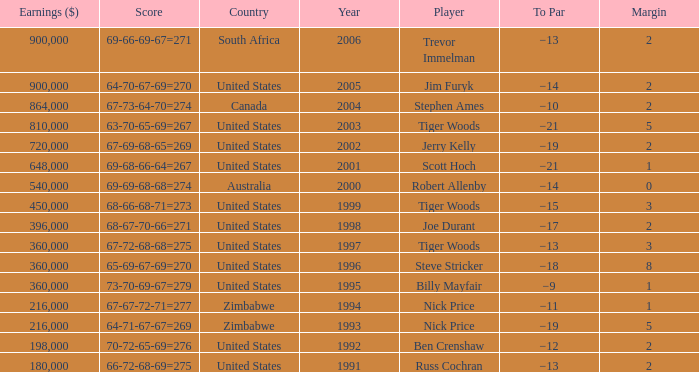Which Margin has a Country of united states, and a Score of 63-70-65-69=267? 5.0. 